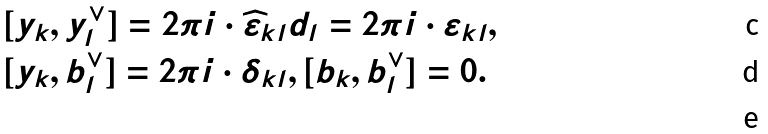Convert formula to latex. <formula><loc_0><loc_0><loc_500><loc_500>& [ { y } _ { k } , { y } ^ { \vee } _ { l } ] = 2 \pi i \cdot \widehat { \varepsilon } _ { k l } d _ { l } = 2 \pi i \cdot \varepsilon _ { k l } , \\ & [ { y } _ { k } , { b } ^ { \vee } _ { l } ] = 2 \pi i \cdot \delta _ { k l } , [ { b } _ { k } , { b } ^ { \vee } _ { l } ] = 0 . \\</formula> 